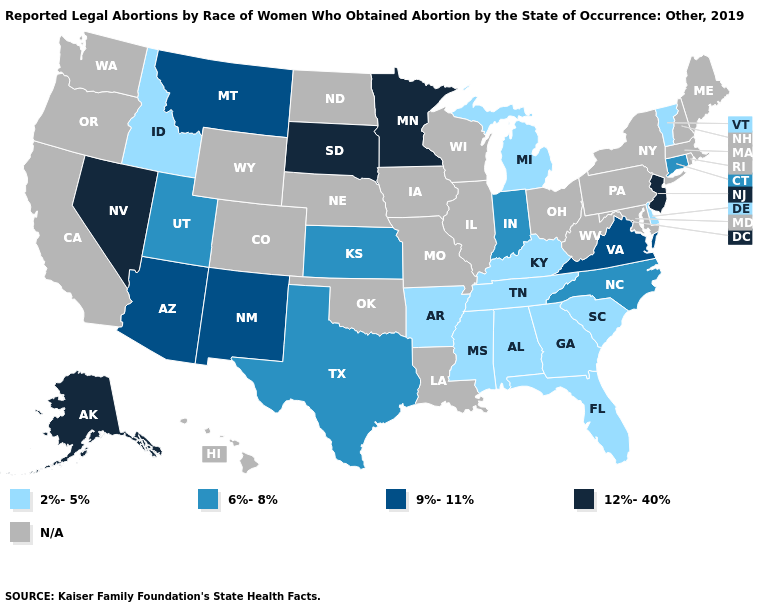Name the states that have a value in the range 6%-8%?
Short answer required. Connecticut, Indiana, Kansas, North Carolina, Texas, Utah. Does the map have missing data?
Keep it brief. Yes. What is the lowest value in the USA?
Be succinct. 2%-5%. Name the states that have a value in the range 2%-5%?
Answer briefly. Alabama, Arkansas, Delaware, Florida, Georgia, Idaho, Kentucky, Michigan, Mississippi, South Carolina, Tennessee, Vermont. Name the states that have a value in the range 9%-11%?
Quick response, please. Arizona, Montana, New Mexico, Virginia. Does Arkansas have the highest value in the South?
Give a very brief answer. No. Among the states that border Michigan , which have the highest value?
Quick response, please. Indiana. Name the states that have a value in the range 9%-11%?
Short answer required. Arizona, Montana, New Mexico, Virginia. What is the lowest value in the West?
Write a very short answer. 2%-5%. What is the value of Wyoming?
Keep it brief. N/A. What is the value of Kentucky?
Keep it brief. 2%-5%. What is the highest value in the Northeast ?
Concise answer only. 12%-40%. What is the value of Ohio?
Short answer required. N/A. Does New Jersey have the highest value in the Northeast?
Be succinct. Yes. 